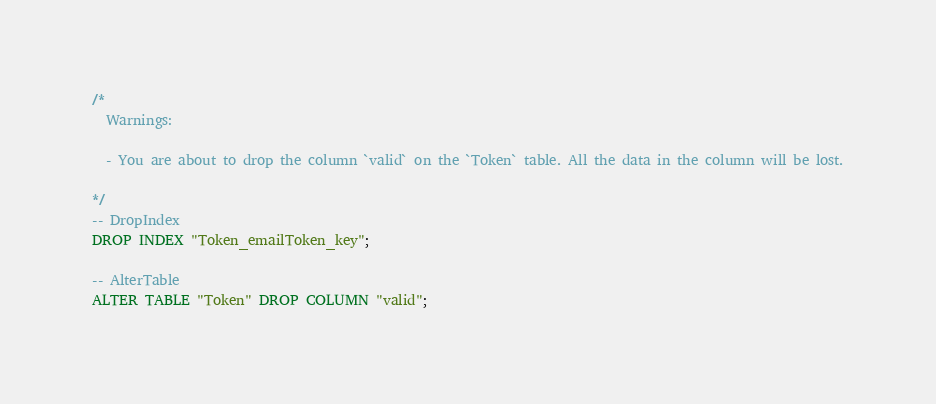Convert code to text. <code><loc_0><loc_0><loc_500><loc_500><_SQL_>/*
  Warnings:

  - You are about to drop the column `valid` on the `Token` table. All the data in the column will be lost.

*/
-- DropIndex
DROP INDEX "Token_emailToken_key";

-- AlterTable
ALTER TABLE "Token" DROP COLUMN "valid";
</code> 